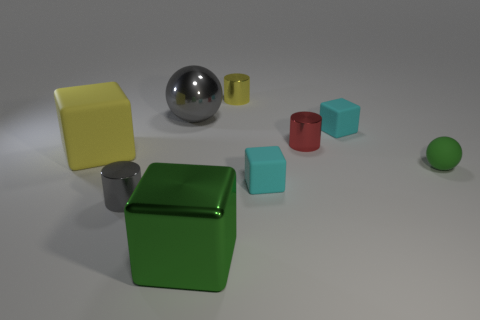Subtract all cyan cubes. How many were subtracted if there are1cyan cubes left? 1 Add 1 tiny red objects. How many objects exist? 10 Subtract all small gray cylinders. How many cylinders are left? 2 Subtract all green cubes. How many cubes are left? 3 Subtract 2 spheres. How many spheres are left? 0 Subtract all balls. How many objects are left? 7 Subtract all gray rubber cylinders. Subtract all gray metal cylinders. How many objects are left? 8 Add 6 tiny yellow objects. How many tiny yellow objects are left? 7 Add 2 big brown spheres. How many big brown spheres exist? 2 Subtract 0 yellow spheres. How many objects are left? 9 